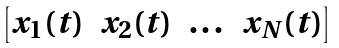Convert formula to latex. <formula><loc_0><loc_0><loc_500><loc_500>\begin{bmatrix} x _ { 1 } ( t ) & x _ { 2 } ( t ) & \dots & x _ { N } ( t ) \end{bmatrix}</formula> 